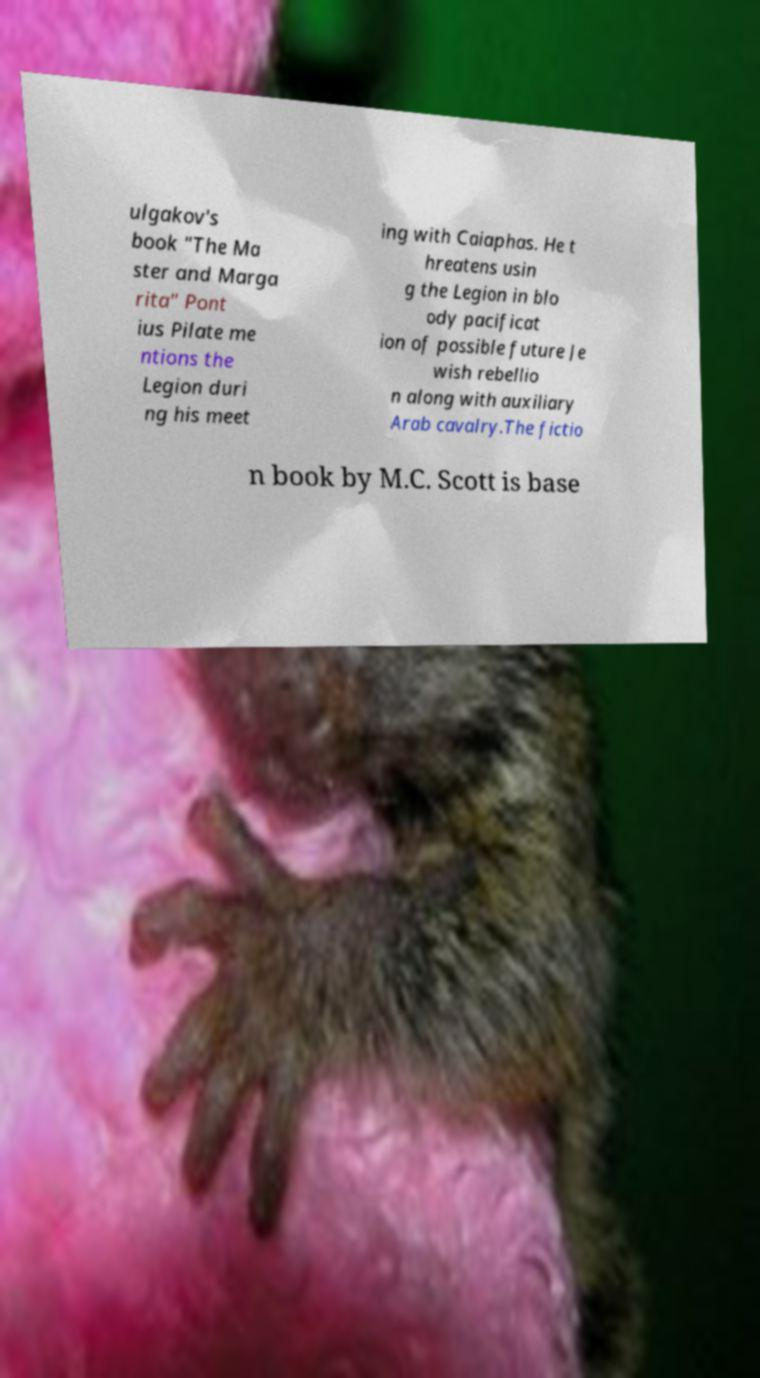Could you extract and type out the text from this image? ulgakov's book "The Ma ster and Marga rita" Pont ius Pilate me ntions the Legion duri ng his meet ing with Caiaphas. He t hreatens usin g the Legion in blo ody pacificat ion of possible future Je wish rebellio n along with auxiliary Arab cavalry.The fictio n book by M.C. Scott is base 